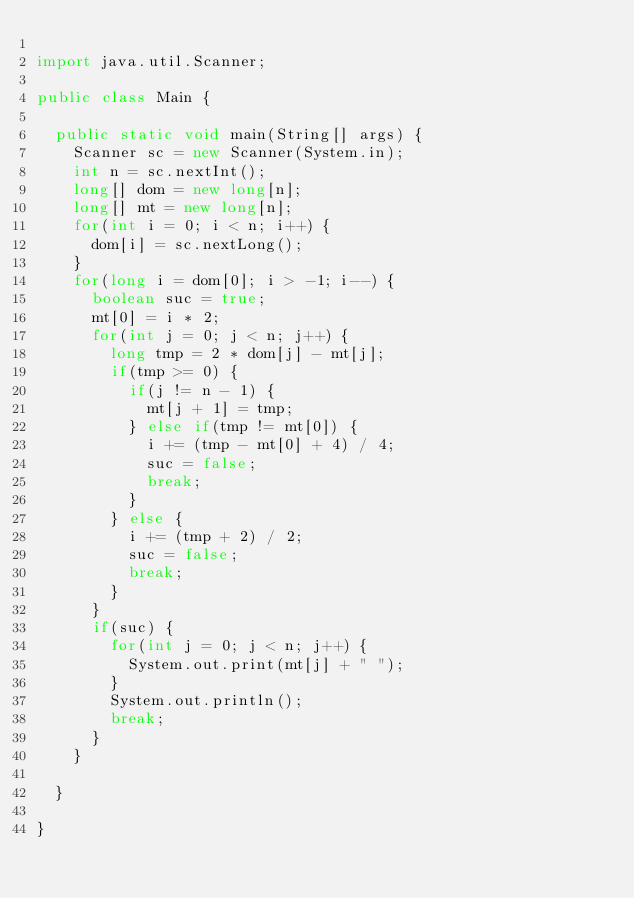<code> <loc_0><loc_0><loc_500><loc_500><_Java_>
import java.util.Scanner;

public class Main {

	public static void main(String[] args) {
		Scanner sc = new Scanner(System.in);
		int n = sc.nextInt();
		long[] dom = new long[n];
		long[] mt = new long[n];
		for(int i = 0; i < n; i++) {
			dom[i] = sc.nextLong();
		}
		for(long i = dom[0]; i > -1; i--) {
			boolean suc = true;
			mt[0] = i * 2;
			for(int j = 0; j < n; j++) {
				long tmp = 2 * dom[j] - mt[j];
				if(tmp >= 0) {
					if(j != n - 1) {
						mt[j + 1] = tmp;
					} else if(tmp != mt[0]) {
						i += (tmp - mt[0] + 4) / 4;
						suc = false;
						break;
					}
				} else {
					i += (tmp + 2) / 2;
					suc = false;
					break;
				}
			}
			if(suc) {
				for(int j = 0; j < n; j++) {
					System.out.print(mt[j] + " ");
				}
				System.out.println();
				break;
			}
		}

	}

}
</code> 